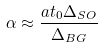Convert formula to latex. <formula><loc_0><loc_0><loc_500><loc_500>\alpha \approx \frac { a t _ { 0 } \Delta _ { S O } } { \Delta _ { B G } }</formula> 